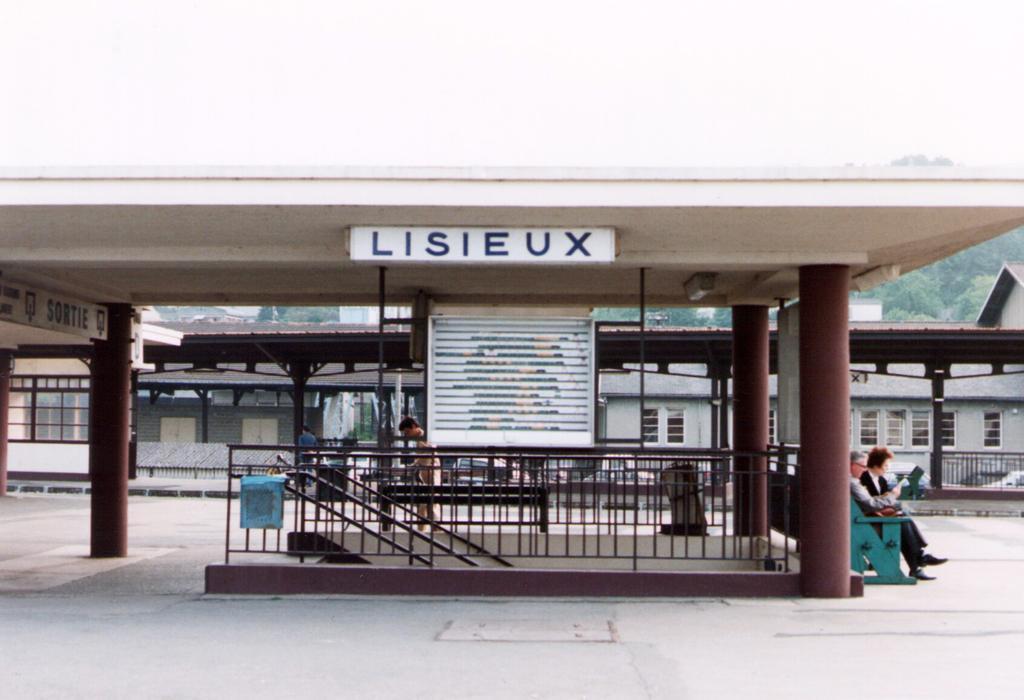Can you describe this image briefly? In this image I can see buildings. There are pillars, name boards and stair case holders. Also there are few people. 